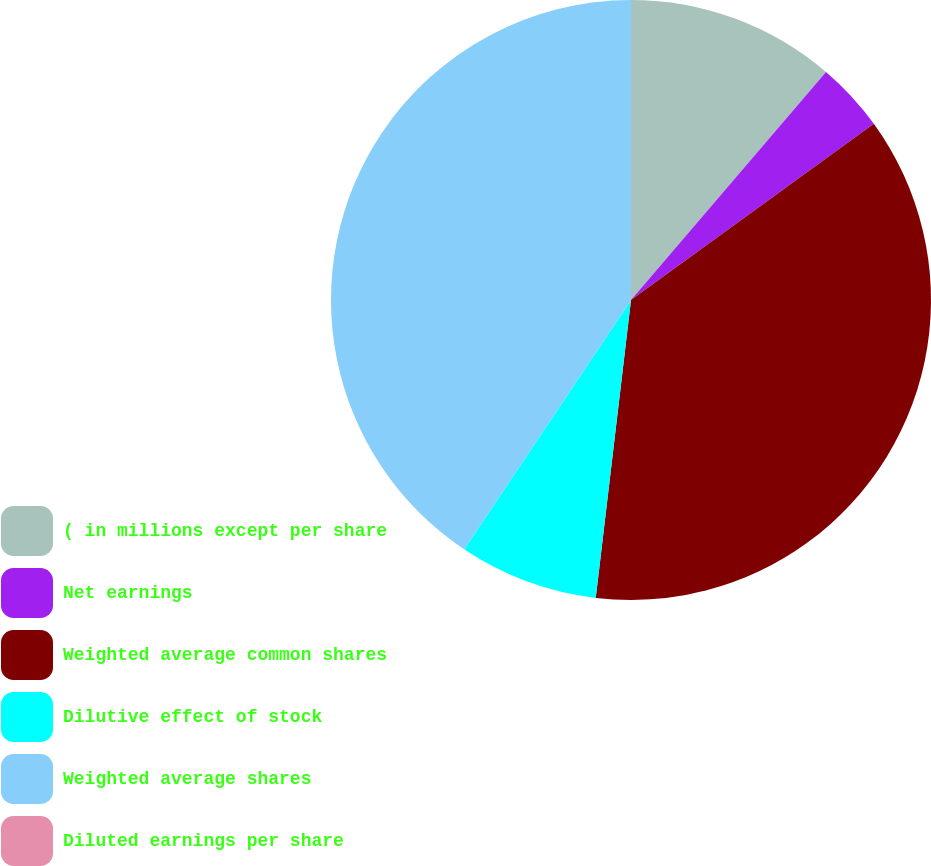<chart> <loc_0><loc_0><loc_500><loc_500><pie_chart><fcel>( in millions except per share<fcel>Net earnings<fcel>Weighted average common shares<fcel>Dilutive effect of stock<fcel>Weighted average shares<fcel>Diluted earnings per share<nl><fcel>11.26%<fcel>3.75%<fcel>36.86%<fcel>7.51%<fcel>40.61%<fcel>0.0%<nl></chart> 